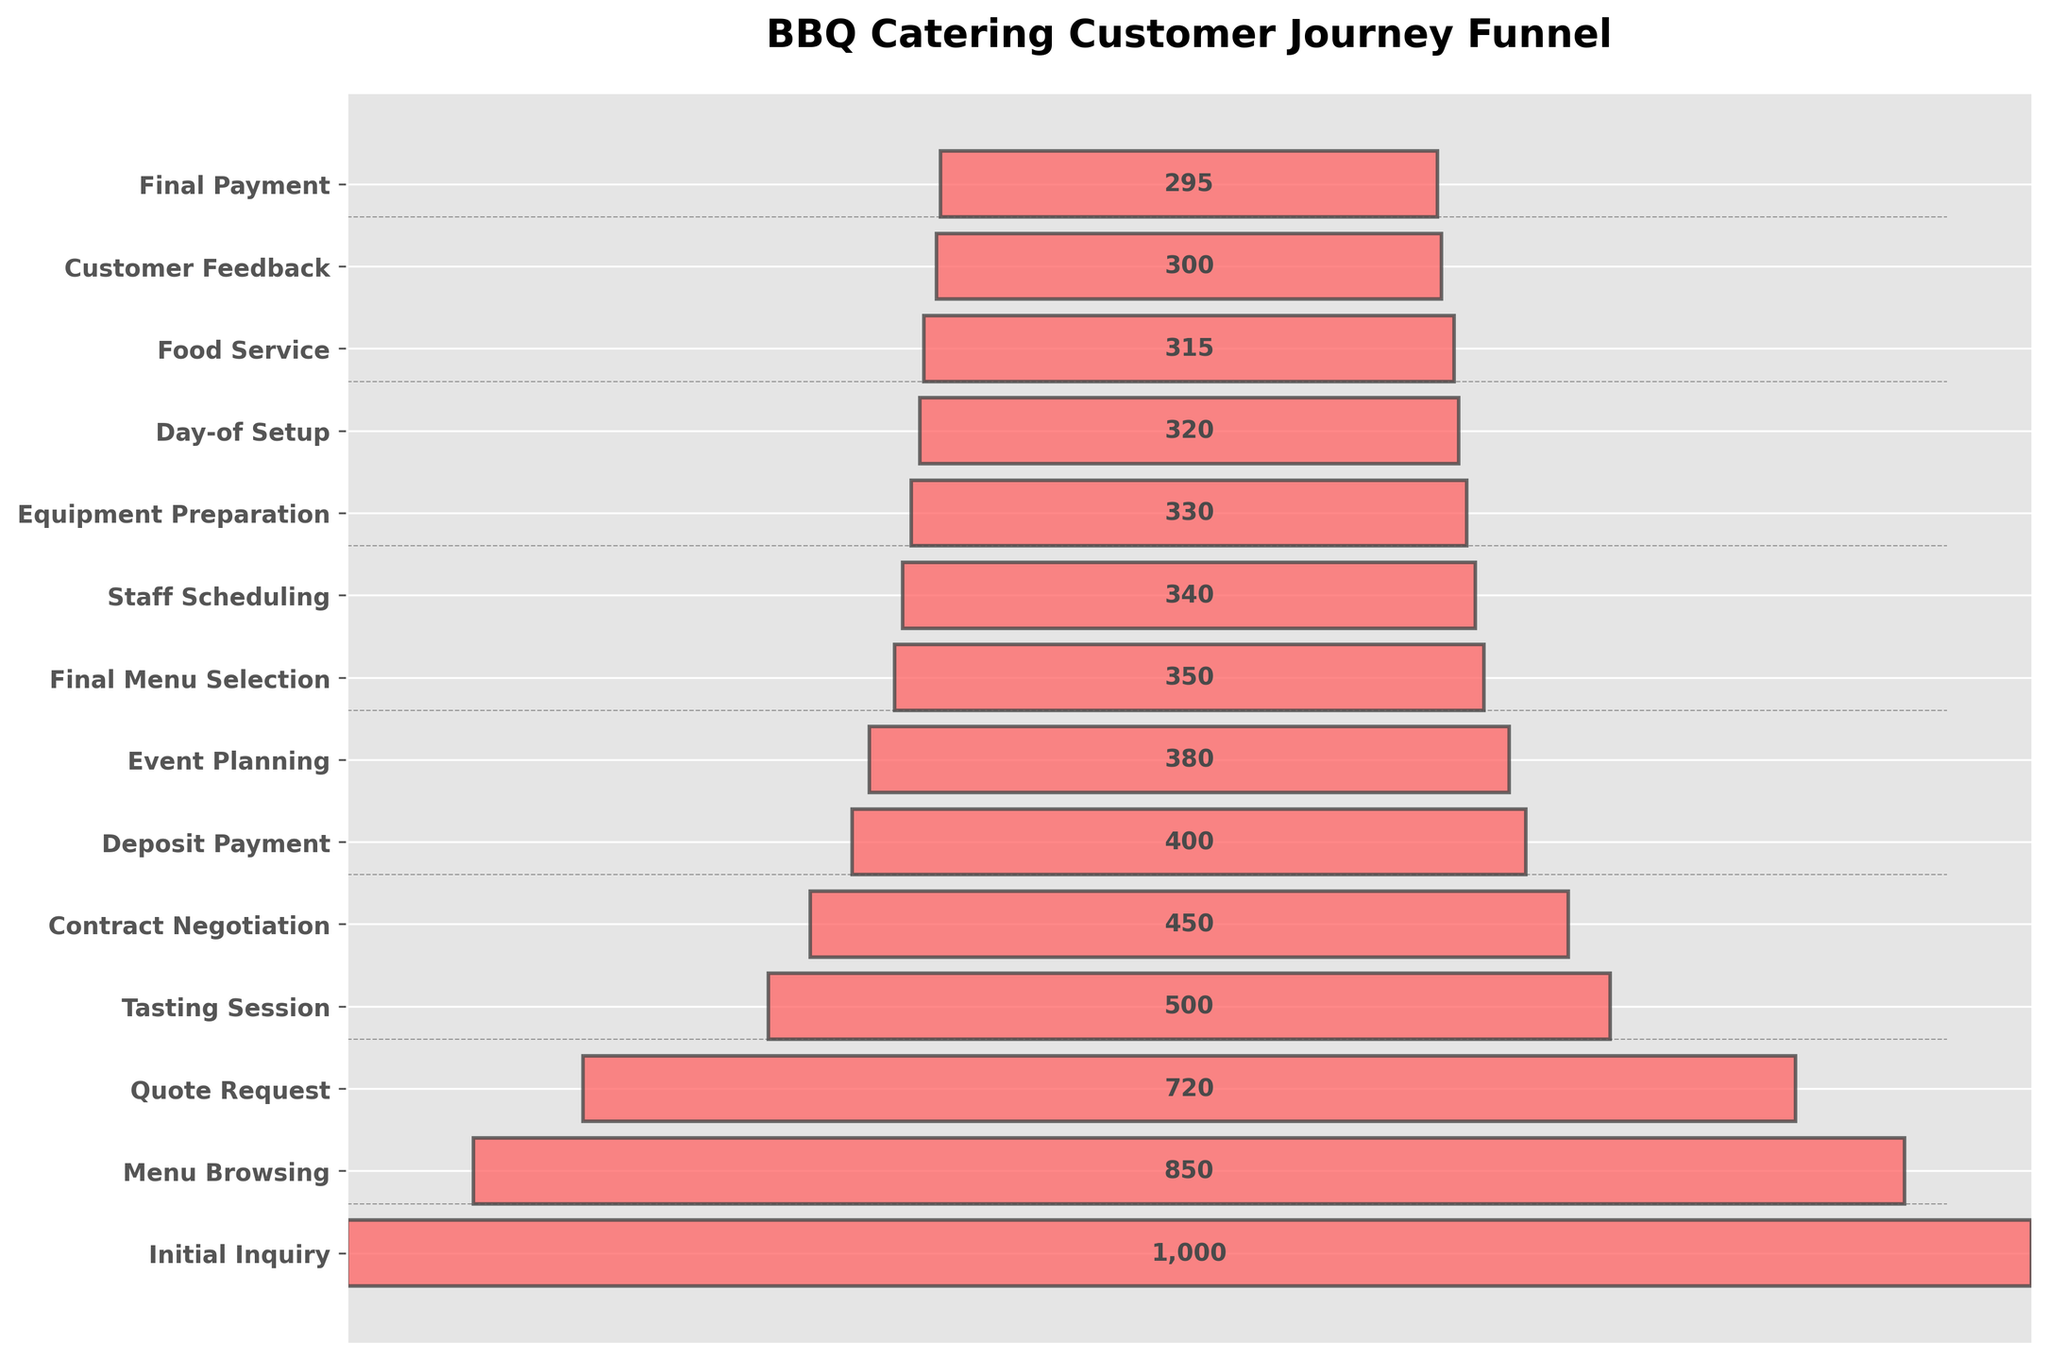What is the title of the funnel chart? The title is located at the top of the figure and describes the overall subject of the chart. It reads "BBQ Catering Customer Journey Funnel."
Answer: BBQ Catering Customer Journey Funnel How many stages are represented in the funnel chart? Count the number of y-ticks or stage labels on the left side of the chart. There are 13 stages listed.
Answer: 13 Which stage has the highest count of customers? Look for the longest bar in the funnel chart; it's the first stage, "Initial Inquiry," with a count of 1,000.
Answer: Initial Inquiry What is the count difference between the 'Quote Request' and 'Tasting Session' stages? Subtract the count of the 'Tasting Session' (500) from the count of the 'Quote Request' (720): 720 - 500 = 220.
Answer: 220 How many stages have a count greater than 500? Identify and count the stages where the count is greater than 500. These stages are 'Initial Inquiry' (1000), 'Menu Browsing' (850), 'Quote Request' (720): three stages.
Answer: 3 Which stages have counts lower than the 'Deposit Payment' stage? Identify stages with counts less than the 'Deposit Payment' count of 400. These stages are: 'Event Planning' (380), 'Final Menu Selection' (350), 'Staff Scheduling' (340), 'Equipment Preparation' (330), 'Day-of Setup' (320), 'Food Service' (315), 'Customer Feedback' (300), and 'Final Payment' (295).
Answer: 8 stages What is the count difference between the first and last stages of the funnel? Subtract the count of the last stage 'Final Payment' (295) from the first stage 'Initial Inquiry' (1000): 1000 - 295 = 705.
Answer: 705 At which stage do the fewest customers drop off compared to the previous stage? Calculate the differences between subsequent stages and look for the smallest drop-off. The smallest drop-off is between 'Equipment Preparation' (330) and 'Staff Scheduling' (340): 340 - 330 = 10.
Answer: Between Equipment Preparation and Staff Scheduling What is the average count of customers from 'Quote Request' to 'Final Payment' stages? Sum the counts from 'Quote Request' (720) to 'Final Payment' (295) and divide by the number of these stages (11 stages). Total sum: 720 + 500 + 450 + 400 + 380 + 350 + 340 + 330 + 320 + 315 + 300 + 295 = 4400. Average: 4400 / 11 = 400.
Answer: 400 In which stage does the largest percentage drop-off occur from the previous stage? Calculate the percentage drop-off for each stage by comparing it to the previous stage. The largest percentage drop-off is from 'Initial Inquiry' (1000) to 'Menu Browsing' (850): (1000-850)/1000 * 100 = 15%.
Answer: From Initial Inquiry to Menu Browsing 